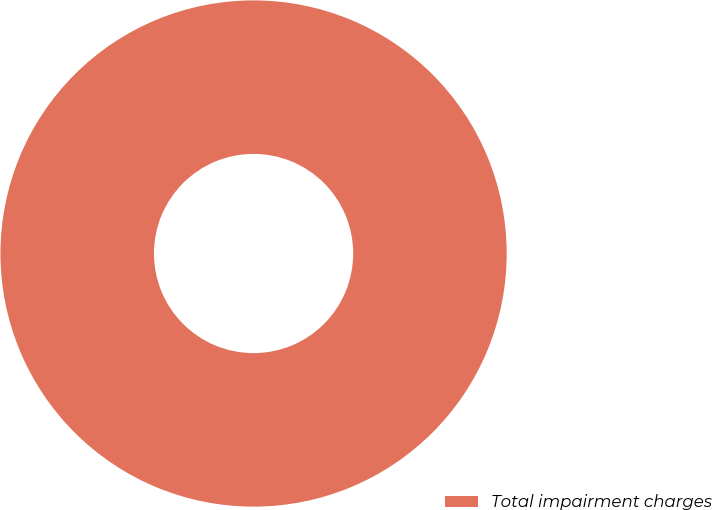Convert chart to OTSL. <chart><loc_0><loc_0><loc_500><loc_500><pie_chart><fcel>Total impairment charges<nl><fcel>100.0%<nl></chart> 